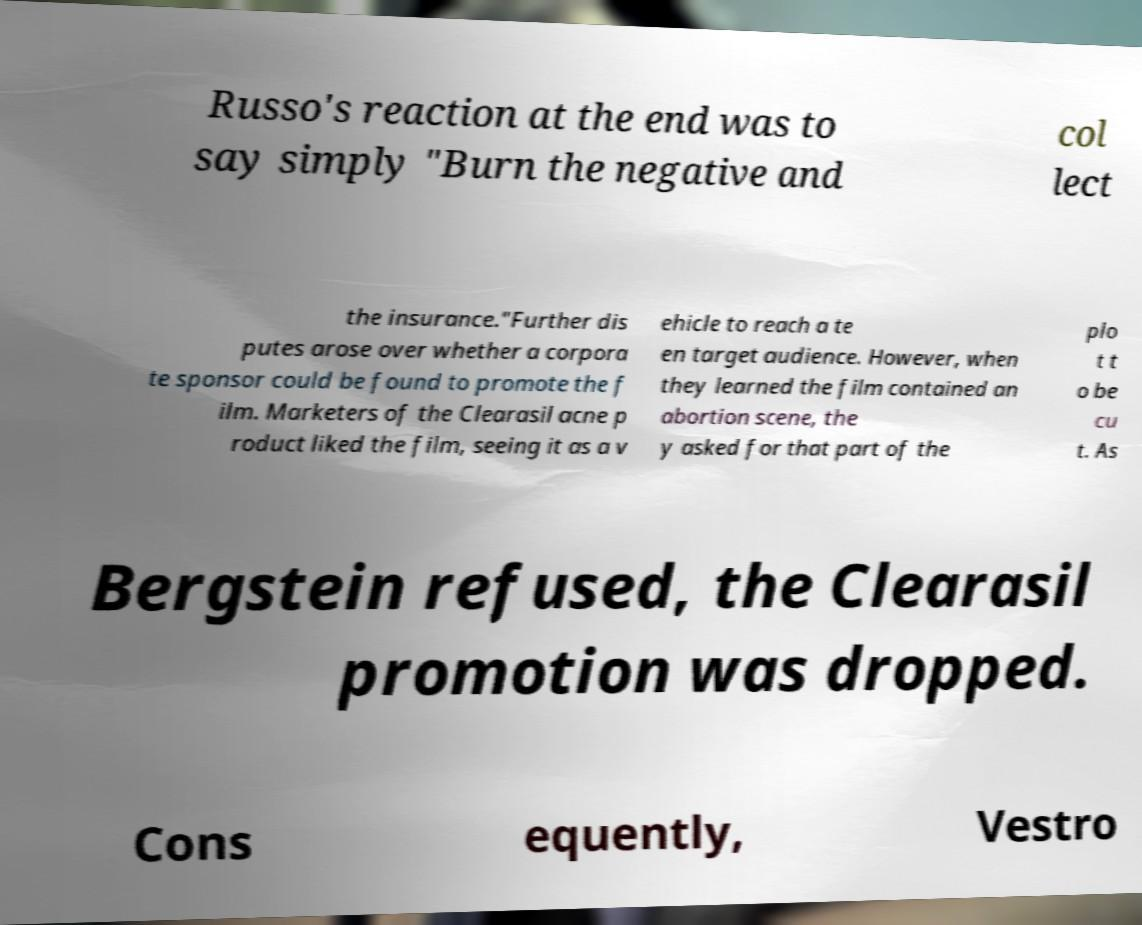Please identify and transcribe the text found in this image. Russo's reaction at the end was to say simply "Burn the negative and col lect the insurance."Further dis putes arose over whether a corpora te sponsor could be found to promote the f ilm. Marketers of the Clearasil acne p roduct liked the film, seeing it as a v ehicle to reach a te en target audience. However, when they learned the film contained an abortion scene, the y asked for that part of the plo t t o be cu t. As Bergstein refused, the Clearasil promotion was dropped. Cons equently, Vestro 